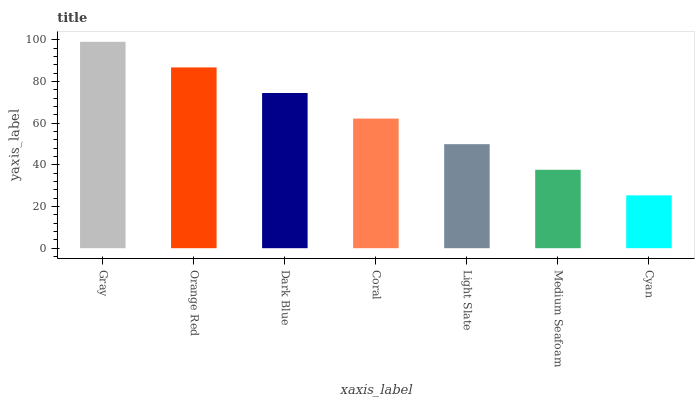Is Cyan the minimum?
Answer yes or no. Yes. Is Gray the maximum?
Answer yes or no. Yes. Is Orange Red the minimum?
Answer yes or no. No. Is Orange Red the maximum?
Answer yes or no. No. Is Gray greater than Orange Red?
Answer yes or no. Yes. Is Orange Red less than Gray?
Answer yes or no. Yes. Is Orange Red greater than Gray?
Answer yes or no. No. Is Gray less than Orange Red?
Answer yes or no. No. Is Coral the high median?
Answer yes or no. Yes. Is Coral the low median?
Answer yes or no. Yes. Is Medium Seafoam the high median?
Answer yes or no. No. Is Orange Red the low median?
Answer yes or no. No. 